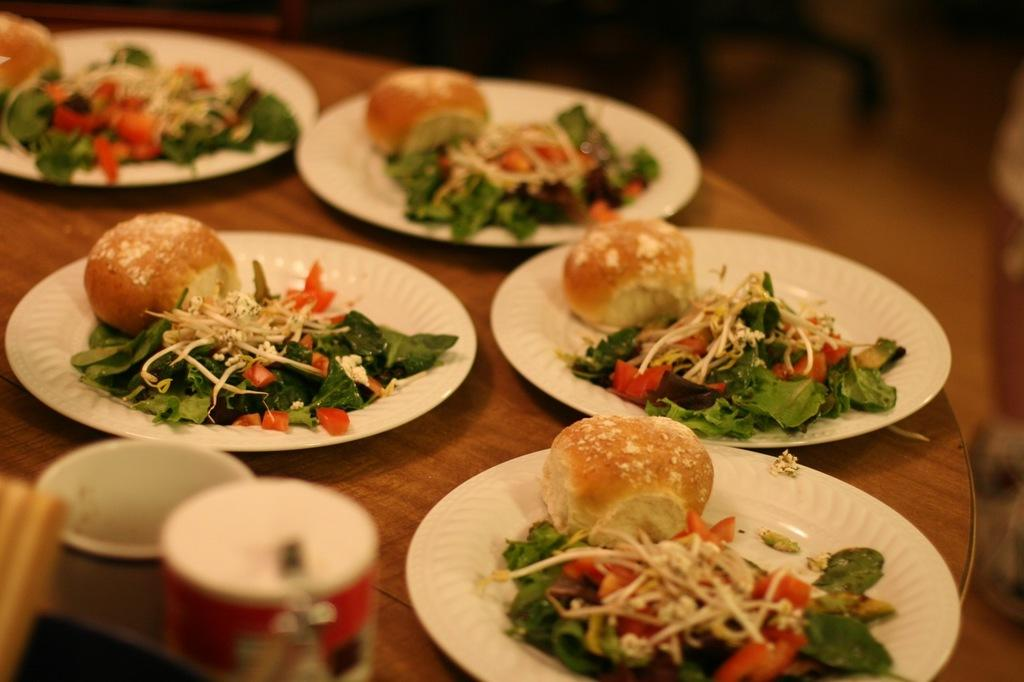What type of food is on the plates in the image? There are buns and salads on plates in the image. Where are the plates with food located? The plates are placed on a table in the image. What else can be seen on the table besides the plates with food? There are other objects on the table in the image. What type of government is depicted in the image? There is no depiction of a government in the image; it features plates with buns and salads on a table. Can you hear any thunder in the image? There is no sound in the image, and therefore no thunder can be heard. 